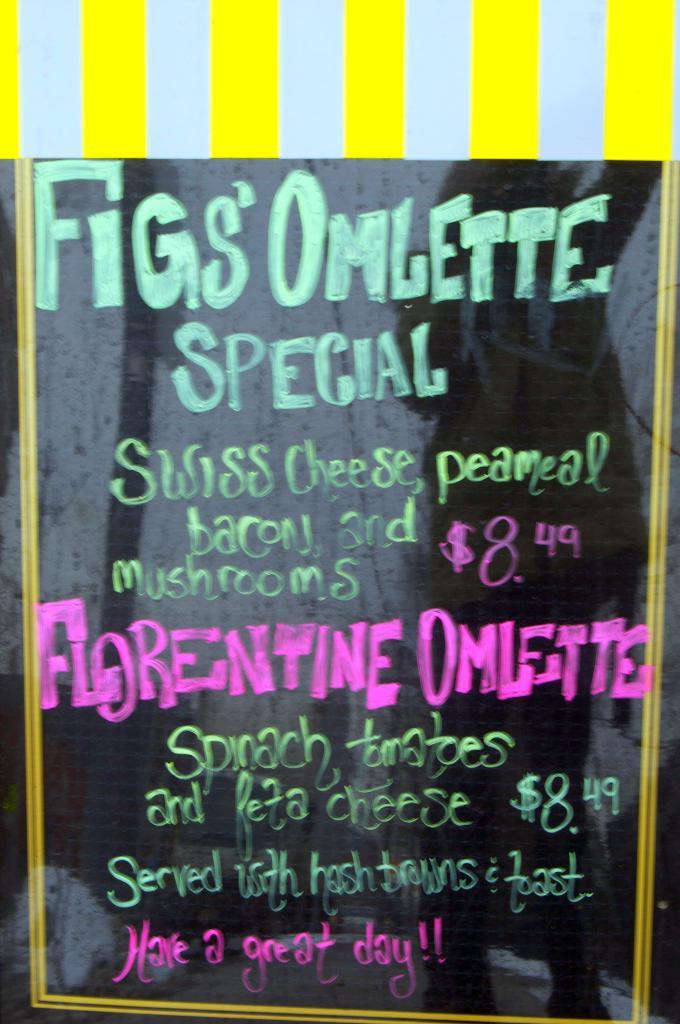What is the special on the menu?
Ensure brevity in your answer.  Figs' omlette. How much does the fig's omlette special cost?
Your response must be concise. $8.49. 